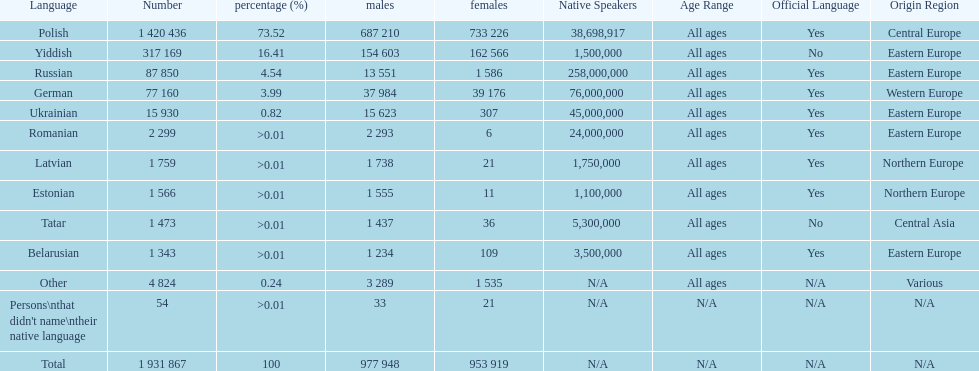What are all the spoken languages? Polish, Yiddish, Russian, German, Ukrainian, Romanian, Latvian, Estonian, Tatar, Belarusian. Which one of these has the most people speaking it? Polish. 